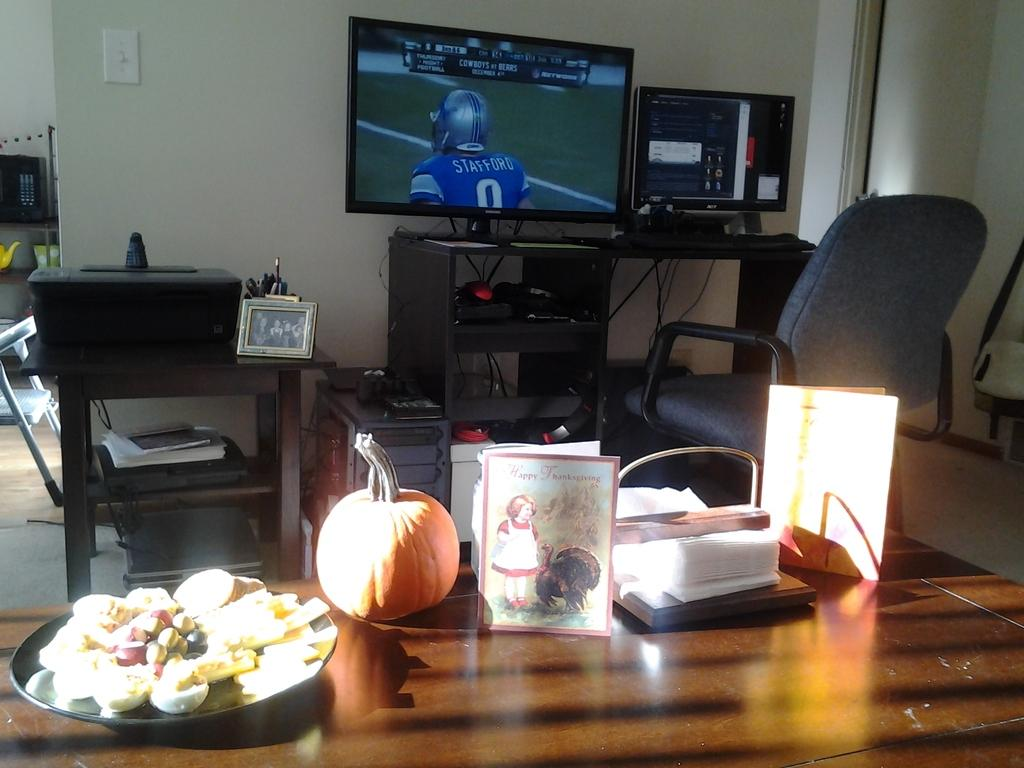What objects can be seen on the table in the image? The facts do not specify which items are on the table, so we cannot answer this question definitively. What is located in the background of the image? There is a photo frame and a television in the background of the image. What type of mist is visible around the television in the image? There is no mist visible in the image; it only features a photo frame and a television in the background. 